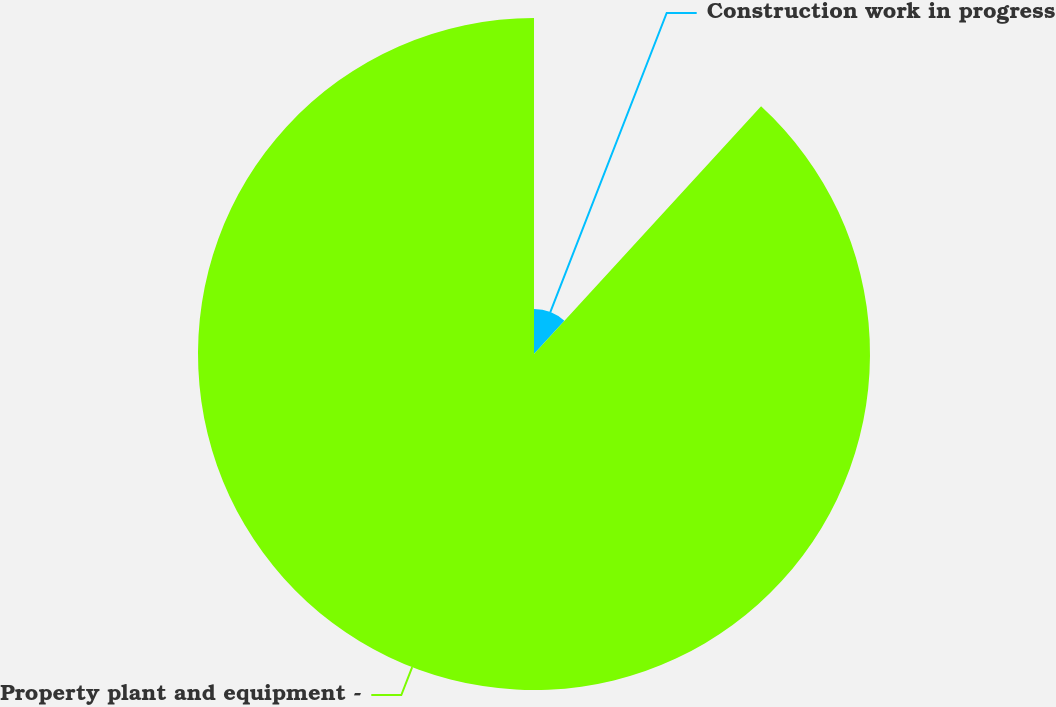Convert chart to OTSL. <chart><loc_0><loc_0><loc_500><loc_500><pie_chart><fcel>Construction work in progress<fcel>Property plant and equipment -<nl><fcel>11.81%<fcel>88.19%<nl></chart> 